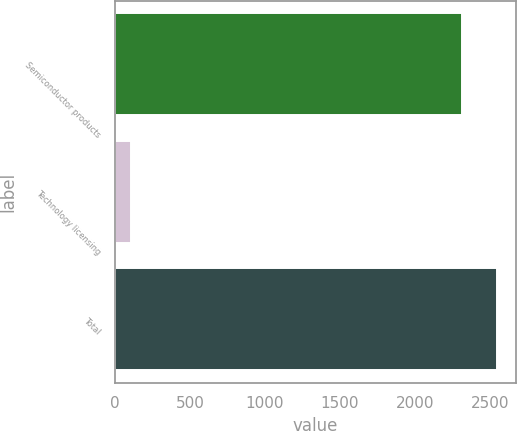<chart> <loc_0><loc_0><loc_500><loc_500><bar_chart><fcel>Semiconductor products<fcel>Technology licensing<fcel>Total<nl><fcel>2315.9<fcel>104.8<fcel>2547.49<nl></chart> 